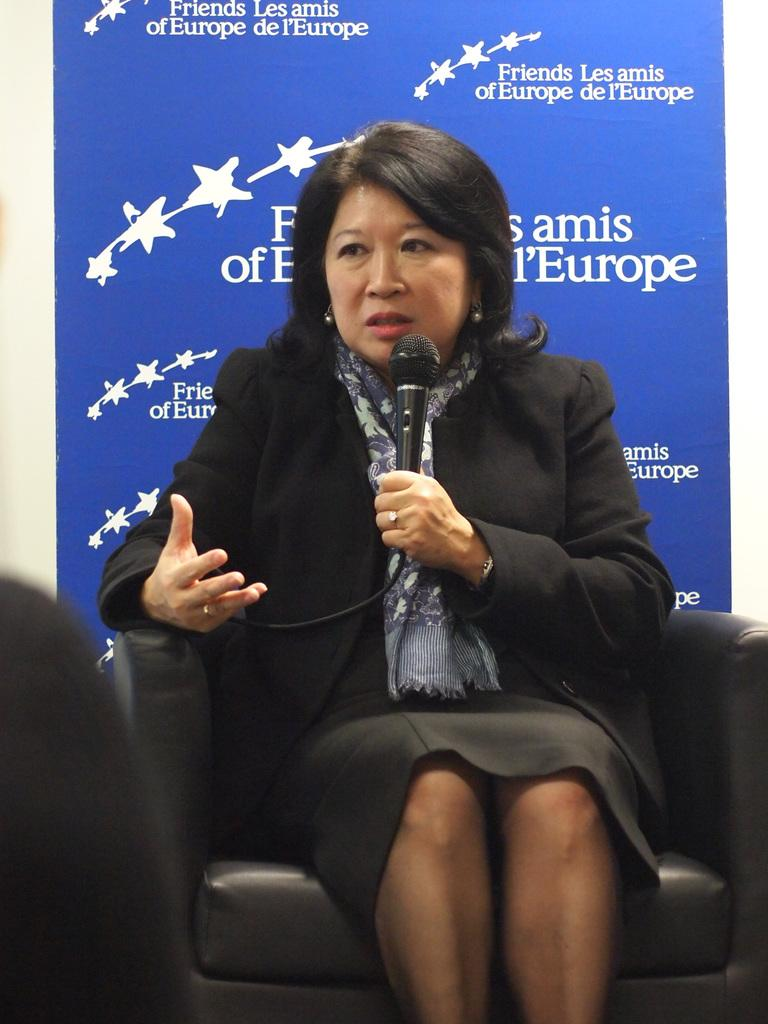Who is the main subject in the image? There is a woman in the image. What is the woman doing in the image? The woman is sitting on a chair and holding a mic in her hand. What type of vacation is the woman planning based on the image? There is no information about a vacation in the image; it only shows the woman sitting on a chair and holding a mic. 